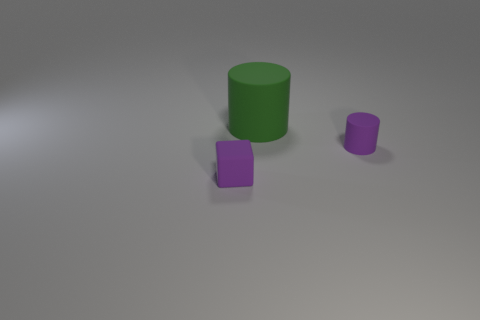Subtract all purple cylinders. How many cylinders are left? 1 Subtract all cubes. How many objects are left? 2 Add 2 big brown blocks. How many objects exist? 5 Subtract all large purple spheres. Subtract all small rubber blocks. How many objects are left? 2 Add 1 small rubber cylinders. How many small rubber cylinders are left? 2 Add 1 big green cylinders. How many big green cylinders exist? 2 Subtract 0 brown blocks. How many objects are left? 3 Subtract 1 cylinders. How many cylinders are left? 1 Subtract all red cylinders. Subtract all cyan cubes. How many cylinders are left? 2 Subtract all purple blocks. How many red cylinders are left? 0 